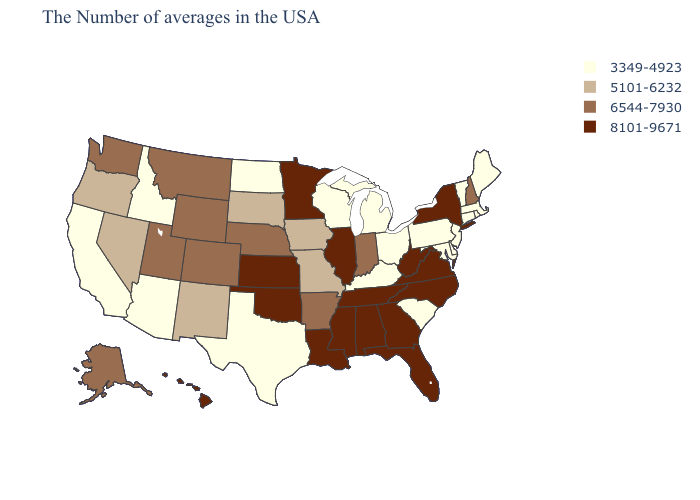Among the states that border Tennessee , which have the lowest value?
Keep it brief. Kentucky. What is the value of Kansas?
Concise answer only. 8101-9671. Does Nebraska have a lower value than Illinois?
Give a very brief answer. Yes. What is the value of Wyoming?
Answer briefly. 6544-7930. How many symbols are there in the legend?
Short answer required. 4. Among the states that border South Carolina , which have the highest value?
Write a very short answer. North Carolina, Georgia. What is the lowest value in states that border Vermont?
Be succinct. 3349-4923. Is the legend a continuous bar?
Give a very brief answer. No. What is the highest value in the USA?
Concise answer only. 8101-9671. Name the states that have a value in the range 6544-7930?
Keep it brief. New Hampshire, Indiana, Arkansas, Nebraska, Wyoming, Colorado, Utah, Montana, Washington, Alaska. Among the states that border Montana , does Idaho have the lowest value?
Short answer required. Yes. Name the states that have a value in the range 8101-9671?
Concise answer only. New York, Virginia, North Carolina, West Virginia, Florida, Georgia, Alabama, Tennessee, Illinois, Mississippi, Louisiana, Minnesota, Kansas, Oklahoma, Hawaii. What is the value of South Carolina?
Quick response, please. 3349-4923. Does Minnesota have the highest value in the MidWest?
Quick response, please. Yes. Name the states that have a value in the range 6544-7930?
Answer briefly. New Hampshire, Indiana, Arkansas, Nebraska, Wyoming, Colorado, Utah, Montana, Washington, Alaska. 